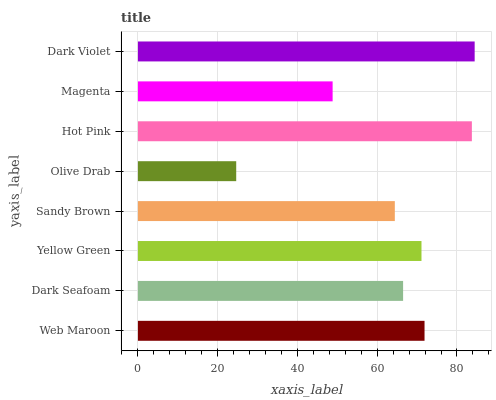Is Olive Drab the minimum?
Answer yes or no. Yes. Is Dark Violet the maximum?
Answer yes or no. Yes. Is Dark Seafoam the minimum?
Answer yes or no. No. Is Dark Seafoam the maximum?
Answer yes or no. No. Is Web Maroon greater than Dark Seafoam?
Answer yes or no. Yes. Is Dark Seafoam less than Web Maroon?
Answer yes or no. Yes. Is Dark Seafoam greater than Web Maroon?
Answer yes or no. No. Is Web Maroon less than Dark Seafoam?
Answer yes or no. No. Is Yellow Green the high median?
Answer yes or no. Yes. Is Dark Seafoam the low median?
Answer yes or no. Yes. Is Dark Seafoam the high median?
Answer yes or no. No. Is Web Maroon the low median?
Answer yes or no. No. 